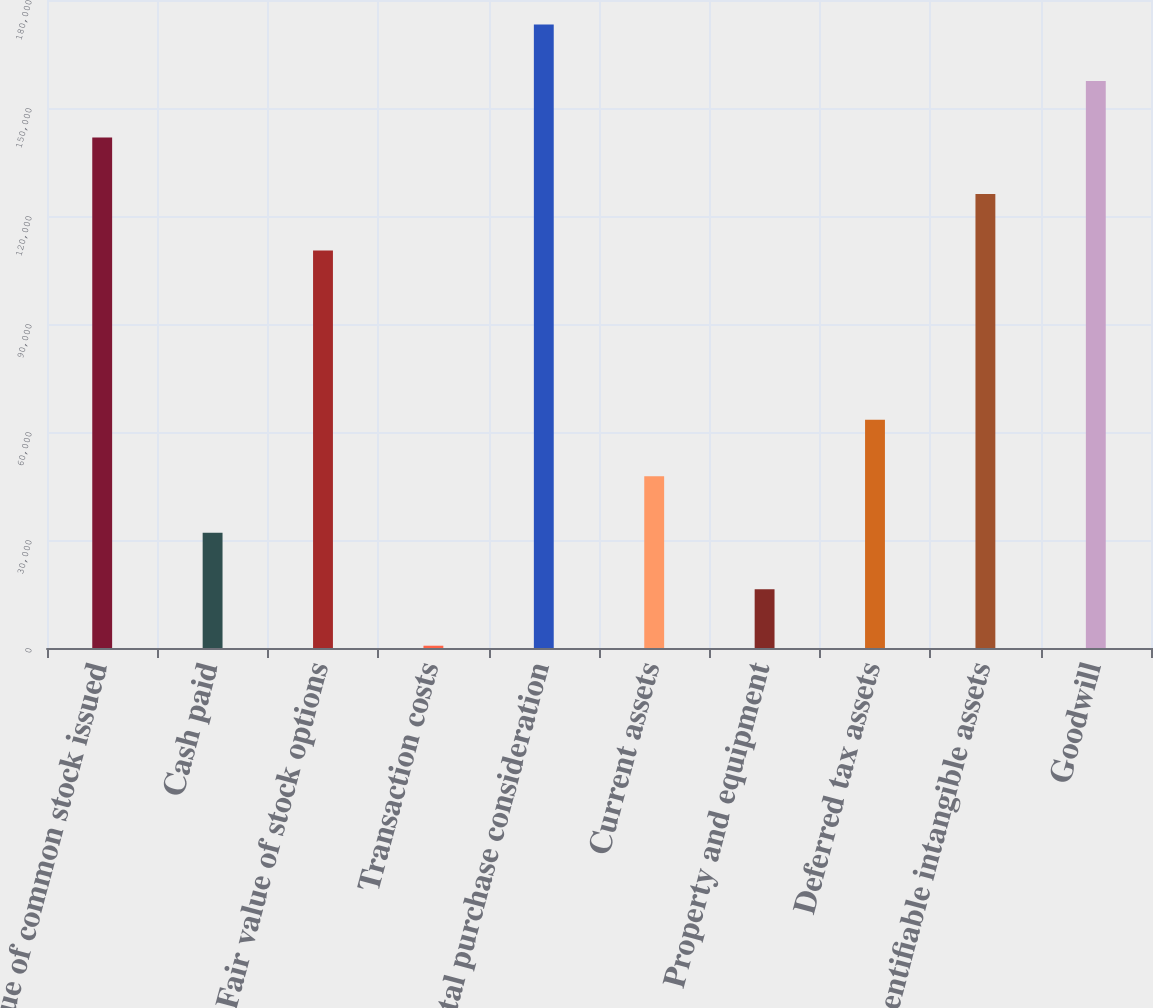<chart> <loc_0><loc_0><loc_500><loc_500><bar_chart><fcel>Value of common stock issued<fcel>Cash paid<fcel>Fair value of stock options<fcel>Transaction costs<fcel>Total purchase consideration<fcel>Current assets<fcel>Property and equipment<fcel>Deferred tax assets<fcel>Identifiable intangible assets<fcel>Goodwill<nl><fcel>141794<fcel>32003<fcel>110426<fcel>634<fcel>173164<fcel>47687.5<fcel>16318.5<fcel>63372<fcel>126110<fcel>157479<nl></chart> 